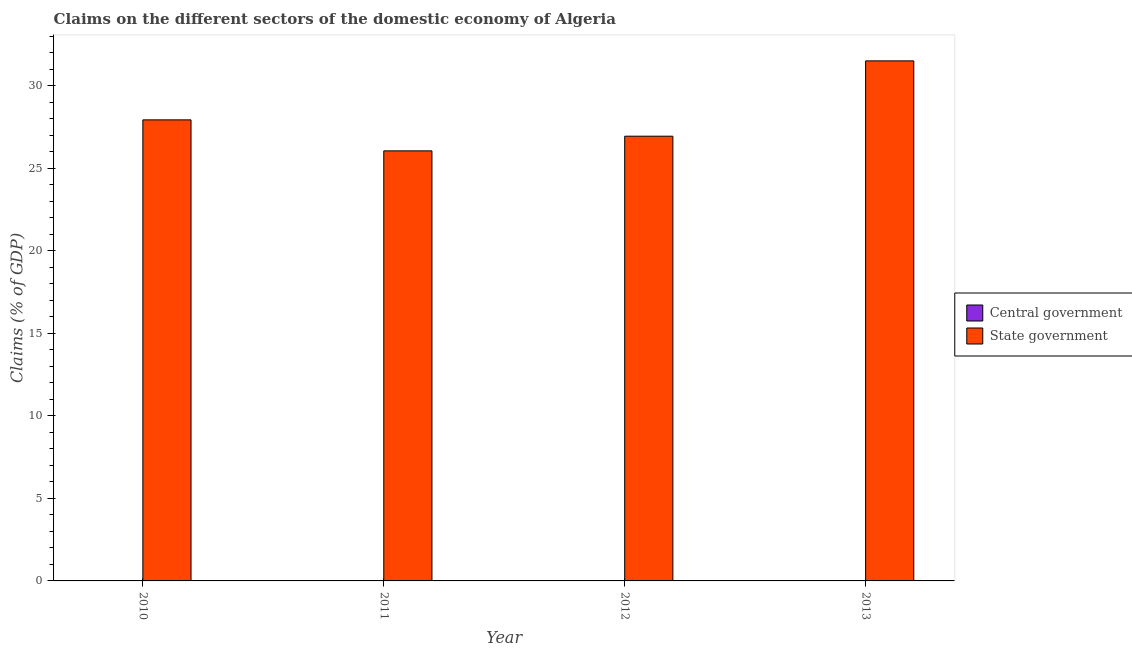How many different coloured bars are there?
Keep it short and to the point. 1. Are the number of bars per tick equal to the number of legend labels?
Your response must be concise. No. Are the number of bars on each tick of the X-axis equal?
Offer a very short reply. Yes. In how many cases, is the number of bars for a given year not equal to the number of legend labels?
Ensure brevity in your answer.  4. What is the claims on central government in 2010?
Provide a succinct answer. 0. Across all years, what is the maximum claims on state government?
Keep it short and to the point. 31.49. Across all years, what is the minimum claims on state government?
Offer a terse response. 26.04. In which year was the claims on state government maximum?
Offer a terse response. 2013. What is the total claims on central government in the graph?
Your response must be concise. 0. What is the difference between the claims on state government in 2012 and that in 2013?
Offer a terse response. -4.56. What is the average claims on state government per year?
Provide a short and direct response. 28.1. What is the ratio of the claims on state government in 2011 to that in 2012?
Ensure brevity in your answer.  0.97. Is the claims on state government in 2010 less than that in 2011?
Give a very brief answer. No. Is the difference between the claims on state government in 2011 and 2012 greater than the difference between the claims on central government in 2011 and 2012?
Make the answer very short. No. What is the difference between the highest and the second highest claims on state government?
Give a very brief answer. 3.57. What is the difference between the highest and the lowest claims on state government?
Provide a succinct answer. 5.45. Are all the bars in the graph horizontal?
Make the answer very short. No. How many years are there in the graph?
Offer a terse response. 4. What is the difference between two consecutive major ticks on the Y-axis?
Offer a terse response. 5. Are the values on the major ticks of Y-axis written in scientific E-notation?
Provide a succinct answer. No. Does the graph contain grids?
Provide a succinct answer. No. How many legend labels are there?
Provide a succinct answer. 2. What is the title of the graph?
Your answer should be compact. Claims on the different sectors of the domestic economy of Algeria. What is the label or title of the Y-axis?
Offer a terse response. Claims (% of GDP). What is the Claims (% of GDP) in State government in 2010?
Make the answer very short. 27.92. What is the Claims (% of GDP) of Central government in 2011?
Your answer should be compact. 0. What is the Claims (% of GDP) in State government in 2011?
Give a very brief answer. 26.04. What is the Claims (% of GDP) in State government in 2012?
Provide a succinct answer. 26.93. What is the Claims (% of GDP) of State government in 2013?
Your response must be concise. 31.49. Across all years, what is the maximum Claims (% of GDP) in State government?
Provide a succinct answer. 31.49. Across all years, what is the minimum Claims (% of GDP) in State government?
Your response must be concise. 26.04. What is the total Claims (% of GDP) of Central government in the graph?
Keep it short and to the point. 0. What is the total Claims (% of GDP) of State government in the graph?
Your answer should be compact. 112.4. What is the difference between the Claims (% of GDP) in State government in 2010 and that in 2011?
Give a very brief answer. 1.88. What is the difference between the Claims (% of GDP) of State government in 2010 and that in 2012?
Offer a very short reply. 0.99. What is the difference between the Claims (% of GDP) of State government in 2010 and that in 2013?
Offer a terse response. -3.57. What is the difference between the Claims (% of GDP) of State government in 2011 and that in 2012?
Provide a succinct answer. -0.89. What is the difference between the Claims (% of GDP) in State government in 2011 and that in 2013?
Your answer should be very brief. -5.45. What is the difference between the Claims (% of GDP) in State government in 2012 and that in 2013?
Keep it short and to the point. -4.56. What is the average Claims (% of GDP) of Central government per year?
Provide a succinct answer. 0. What is the average Claims (% of GDP) of State government per year?
Provide a succinct answer. 28.1. What is the ratio of the Claims (% of GDP) of State government in 2010 to that in 2011?
Make the answer very short. 1.07. What is the ratio of the Claims (% of GDP) of State government in 2010 to that in 2012?
Your response must be concise. 1.04. What is the ratio of the Claims (% of GDP) in State government in 2010 to that in 2013?
Ensure brevity in your answer.  0.89. What is the ratio of the Claims (% of GDP) of State government in 2011 to that in 2012?
Your response must be concise. 0.97. What is the ratio of the Claims (% of GDP) of State government in 2011 to that in 2013?
Provide a succinct answer. 0.83. What is the ratio of the Claims (% of GDP) in State government in 2012 to that in 2013?
Your answer should be compact. 0.86. What is the difference between the highest and the second highest Claims (% of GDP) of State government?
Make the answer very short. 3.57. What is the difference between the highest and the lowest Claims (% of GDP) of State government?
Give a very brief answer. 5.45. 